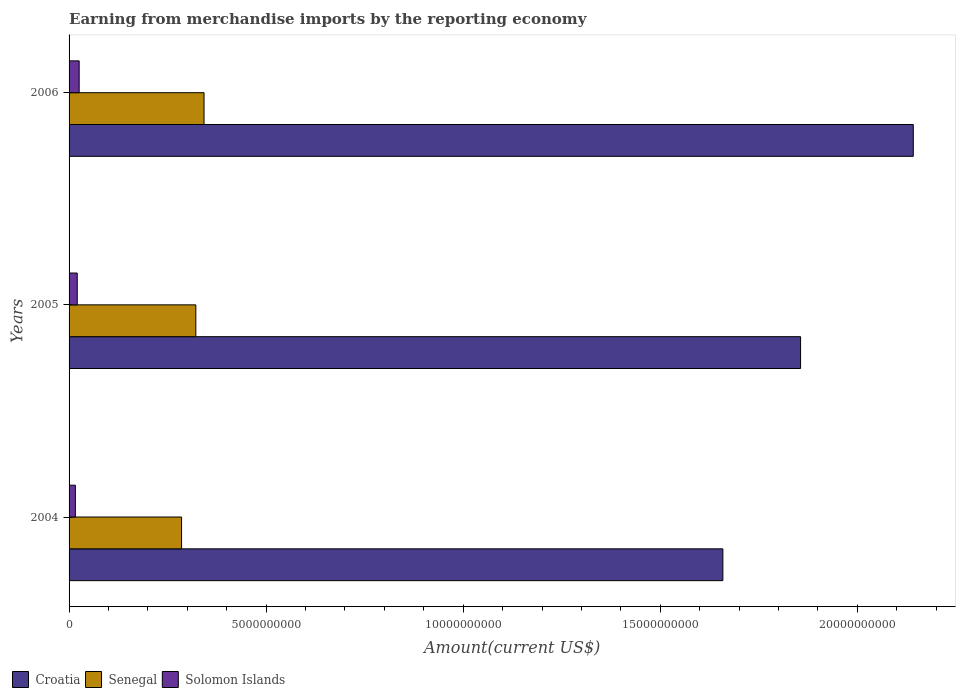How many groups of bars are there?
Provide a short and direct response. 3. Are the number of bars on each tick of the Y-axis equal?
Give a very brief answer. Yes. What is the label of the 2nd group of bars from the top?
Give a very brief answer. 2005. In how many cases, is the number of bars for a given year not equal to the number of legend labels?
Offer a very short reply. 0. What is the amount earned from merchandise imports in Croatia in 2005?
Your answer should be very brief. 1.86e+1. Across all years, what is the maximum amount earned from merchandise imports in Croatia?
Offer a terse response. 2.14e+1. Across all years, what is the minimum amount earned from merchandise imports in Croatia?
Keep it short and to the point. 1.66e+1. In which year was the amount earned from merchandise imports in Senegal maximum?
Give a very brief answer. 2006. What is the total amount earned from merchandise imports in Solomon Islands in the graph?
Your response must be concise. 6.24e+08. What is the difference between the amount earned from merchandise imports in Solomon Islands in 2005 and that in 2006?
Your response must be concise. -4.85e+07. What is the difference between the amount earned from merchandise imports in Croatia in 2004 and the amount earned from merchandise imports in Solomon Islands in 2005?
Keep it short and to the point. 1.64e+1. What is the average amount earned from merchandise imports in Solomon Islands per year?
Provide a succinct answer. 2.08e+08. In the year 2005, what is the difference between the amount earned from merchandise imports in Senegal and amount earned from merchandise imports in Solomon Islands?
Ensure brevity in your answer.  3.01e+09. In how many years, is the amount earned from merchandise imports in Solomon Islands greater than 13000000000 US$?
Provide a short and direct response. 0. What is the ratio of the amount earned from merchandise imports in Solomon Islands in 2004 to that in 2006?
Keep it short and to the point. 0.62. Is the amount earned from merchandise imports in Solomon Islands in 2004 less than that in 2006?
Give a very brief answer. Yes. What is the difference between the highest and the second highest amount earned from merchandise imports in Croatia?
Your response must be concise. 2.86e+09. What is the difference between the highest and the lowest amount earned from merchandise imports in Solomon Islands?
Your answer should be very brief. 9.64e+07. What does the 2nd bar from the top in 2004 represents?
Your answer should be compact. Senegal. What does the 2nd bar from the bottom in 2006 represents?
Keep it short and to the point. Senegal. How many bars are there?
Ensure brevity in your answer.  9. Are all the bars in the graph horizontal?
Give a very brief answer. Yes. What is the difference between two consecutive major ticks on the X-axis?
Provide a succinct answer. 5.00e+09. Does the graph contain any zero values?
Your answer should be very brief. No. Does the graph contain grids?
Your response must be concise. No. Where does the legend appear in the graph?
Offer a very short reply. Bottom left. How are the legend labels stacked?
Provide a short and direct response. Horizontal. What is the title of the graph?
Offer a terse response. Earning from merchandise imports by the reporting economy. Does "Morocco" appear as one of the legend labels in the graph?
Provide a short and direct response. No. What is the label or title of the X-axis?
Ensure brevity in your answer.  Amount(current US$). What is the label or title of the Y-axis?
Keep it short and to the point. Years. What is the Amount(current US$) of Croatia in 2004?
Give a very brief answer. 1.66e+1. What is the Amount(current US$) of Senegal in 2004?
Your answer should be very brief. 2.85e+09. What is the Amount(current US$) of Solomon Islands in 2004?
Provide a succinct answer. 1.60e+08. What is the Amount(current US$) in Croatia in 2005?
Provide a succinct answer. 1.86e+1. What is the Amount(current US$) of Senegal in 2005?
Offer a very short reply. 3.22e+09. What is the Amount(current US$) of Solomon Islands in 2005?
Your response must be concise. 2.08e+08. What is the Amount(current US$) of Croatia in 2006?
Your answer should be very brief. 2.14e+1. What is the Amount(current US$) of Senegal in 2006?
Your response must be concise. 3.42e+09. What is the Amount(current US$) in Solomon Islands in 2006?
Offer a very short reply. 2.56e+08. Across all years, what is the maximum Amount(current US$) in Croatia?
Give a very brief answer. 2.14e+1. Across all years, what is the maximum Amount(current US$) in Senegal?
Keep it short and to the point. 3.42e+09. Across all years, what is the maximum Amount(current US$) in Solomon Islands?
Provide a succinct answer. 2.56e+08. Across all years, what is the minimum Amount(current US$) of Croatia?
Offer a terse response. 1.66e+1. Across all years, what is the minimum Amount(current US$) in Senegal?
Offer a terse response. 2.85e+09. Across all years, what is the minimum Amount(current US$) in Solomon Islands?
Offer a very short reply. 1.60e+08. What is the total Amount(current US$) in Croatia in the graph?
Your response must be concise. 5.66e+1. What is the total Amount(current US$) in Senegal in the graph?
Give a very brief answer. 9.50e+09. What is the total Amount(current US$) in Solomon Islands in the graph?
Offer a very short reply. 6.24e+08. What is the difference between the Amount(current US$) in Croatia in 2004 and that in 2005?
Provide a succinct answer. -1.97e+09. What is the difference between the Amount(current US$) of Senegal in 2004 and that in 2005?
Offer a very short reply. -3.62e+08. What is the difference between the Amount(current US$) in Solomon Islands in 2004 and that in 2005?
Give a very brief answer. -4.79e+07. What is the difference between the Amount(current US$) in Croatia in 2004 and that in 2006?
Give a very brief answer. -4.83e+09. What is the difference between the Amount(current US$) of Senegal in 2004 and that in 2006?
Give a very brief answer. -5.70e+08. What is the difference between the Amount(current US$) in Solomon Islands in 2004 and that in 2006?
Give a very brief answer. -9.64e+07. What is the difference between the Amount(current US$) in Croatia in 2005 and that in 2006?
Your answer should be very brief. -2.86e+09. What is the difference between the Amount(current US$) in Senegal in 2005 and that in 2006?
Your answer should be very brief. -2.08e+08. What is the difference between the Amount(current US$) in Solomon Islands in 2005 and that in 2006?
Your answer should be compact. -4.85e+07. What is the difference between the Amount(current US$) in Croatia in 2004 and the Amount(current US$) in Senegal in 2005?
Provide a succinct answer. 1.34e+1. What is the difference between the Amount(current US$) in Croatia in 2004 and the Amount(current US$) in Solomon Islands in 2005?
Offer a very short reply. 1.64e+1. What is the difference between the Amount(current US$) in Senegal in 2004 and the Amount(current US$) in Solomon Islands in 2005?
Your answer should be compact. 2.65e+09. What is the difference between the Amount(current US$) in Croatia in 2004 and the Amount(current US$) in Senegal in 2006?
Offer a terse response. 1.32e+1. What is the difference between the Amount(current US$) in Croatia in 2004 and the Amount(current US$) in Solomon Islands in 2006?
Offer a terse response. 1.63e+1. What is the difference between the Amount(current US$) of Senegal in 2004 and the Amount(current US$) of Solomon Islands in 2006?
Provide a succinct answer. 2.60e+09. What is the difference between the Amount(current US$) of Croatia in 2005 and the Amount(current US$) of Senegal in 2006?
Give a very brief answer. 1.51e+1. What is the difference between the Amount(current US$) of Croatia in 2005 and the Amount(current US$) of Solomon Islands in 2006?
Provide a succinct answer. 1.83e+1. What is the difference between the Amount(current US$) of Senegal in 2005 and the Amount(current US$) of Solomon Islands in 2006?
Your response must be concise. 2.96e+09. What is the average Amount(current US$) in Croatia per year?
Make the answer very short. 1.89e+1. What is the average Amount(current US$) in Senegal per year?
Make the answer very short. 3.17e+09. What is the average Amount(current US$) of Solomon Islands per year?
Your answer should be very brief. 2.08e+08. In the year 2004, what is the difference between the Amount(current US$) of Croatia and Amount(current US$) of Senegal?
Offer a terse response. 1.37e+1. In the year 2004, what is the difference between the Amount(current US$) in Croatia and Amount(current US$) in Solomon Islands?
Your answer should be very brief. 1.64e+1. In the year 2004, what is the difference between the Amount(current US$) in Senegal and Amount(current US$) in Solomon Islands?
Your answer should be compact. 2.69e+09. In the year 2005, what is the difference between the Amount(current US$) of Croatia and Amount(current US$) of Senegal?
Your answer should be compact. 1.53e+1. In the year 2005, what is the difference between the Amount(current US$) in Croatia and Amount(current US$) in Solomon Islands?
Give a very brief answer. 1.84e+1. In the year 2005, what is the difference between the Amount(current US$) in Senegal and Amount(current US$) in Solomon Islands?
Your response must be concise. 3.01e+09. In the year 2006, what is the difference between the Amount(current US$) in Croatia and Amount(current US$) in Senegal?
Your response must be concise. 1.80e+1. In the year 2006, what is the difference between the Amount(current US$) of Croatia and Amount(current US$) of Solomon Islands?
Your response must be concise. 2.12e+1. In the year 2006, what is the difference between the Amount(current US$) of Senegal and Amount(current US$) of Solomon Islands?
Make the answer very short. 3.17e+09. What is the ratio of the Amount(current US$) in Croatia in 2004 to that in 2005?
Provide a succinct answer. 0.89. What is the ratio of the Amount(current US$) in Senegal in 2004 to that in 2005?
Give a very brief answer. 0.89. What is the ratio of the Amount(current US$) of Solomon Islands in 2004 to that in 2005?
Provide a succinct answer. 0.77. What is the ratio of the Amount(current US$) of Croatia in 2004 to that in 2006?
Ensure brevity in your answer.  0.77. What is the ratio of the Amount(current US$) of Senegal in 2004 to that in 2006?
Keep it short and to the point. 0.83. What is the ratio of the Amount(current US$) of Solomon Islands in 2004 to that in 2006?
Give a very brief answer. 0.62. What is the ratio of the Amount(current US$) of Croatia in 2005 to that in 2006?
Your answer should be compact. 0.87. What is the ratio of the Amount(current US$) in Senegal in 2005 to that in 2006?
Keep it short and to the point. 0.94. What is the ratio of the Amount(current US$) of Solomon Islands in 2005 to that in 2006?
Your answer should be very brief. 0.81. What is the difference between the highest and the second highest Amount(current US$) in Croatia?
Offer a very short reply. 2.86e+09. What is the difference between the highest and the second highest Amount(current US$) in Senegal?
Offer a very short reply. 2.08e+08. What is the difference between the highest and the second highest Amount(current US$) in Solomon Islands?
Give a very brief answer. 4.85e+07. What is the difference between the highest and the lowest Amount(current US$) in Croatia?
Your answer should be compact. 4.83e+09. What is the difference between the highest and the lowest Amount(current US$) in Senegal?
Your response must be concise. 5.70e+08. What is the difference between the highest and the lowest Amount(current US$) in Solomon Islands?
Your answer should be very brief. 9.64e+07. 